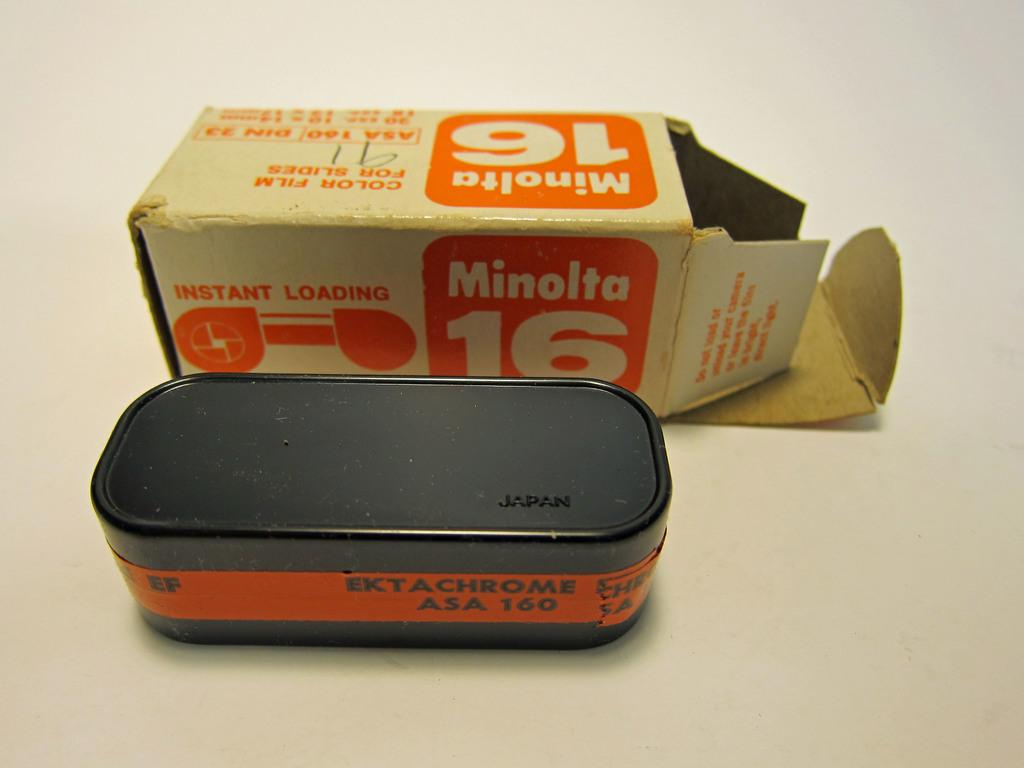<image>
Create a compact narrative representing the image presented. a box for Minolta Instant Loading film from Japan 